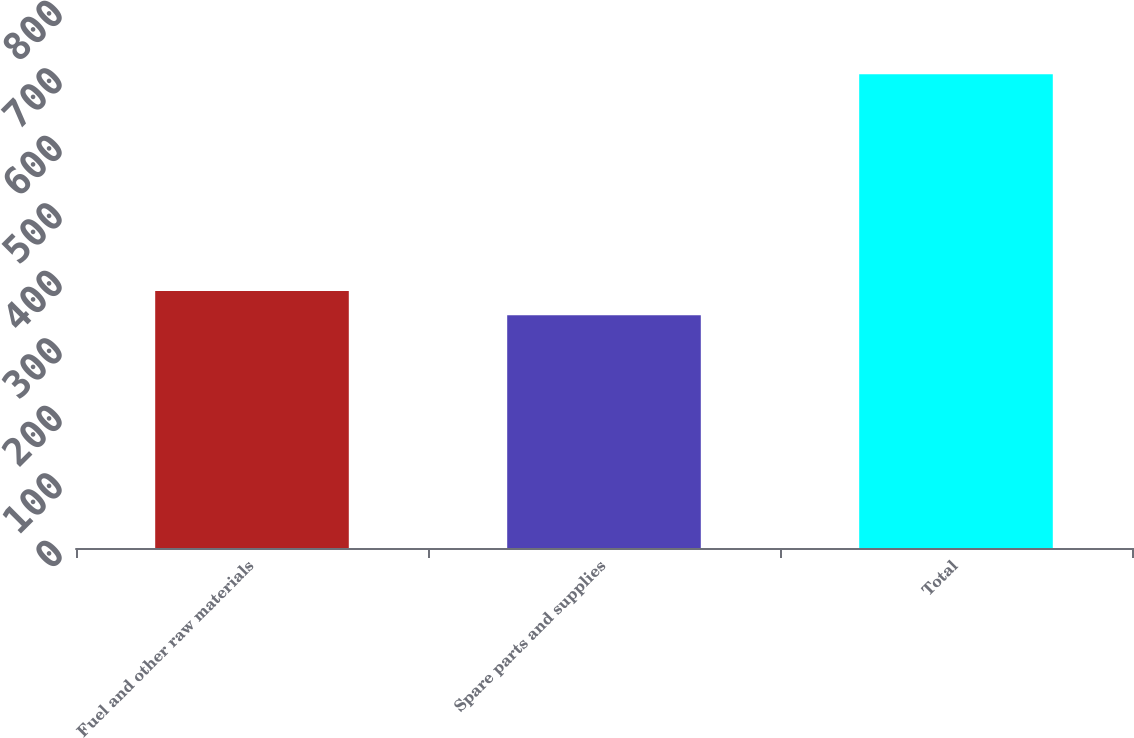Convert chart to OTSL. <chart><loc_0><loc_0><loc_500><loc_500><bar_chart><fcel>Fuel and other raw materials<fcel>Spare parts and supplies<fcel>Total<nl><fcel>380.7<fcel>345<fcel>702<nl></chart> 